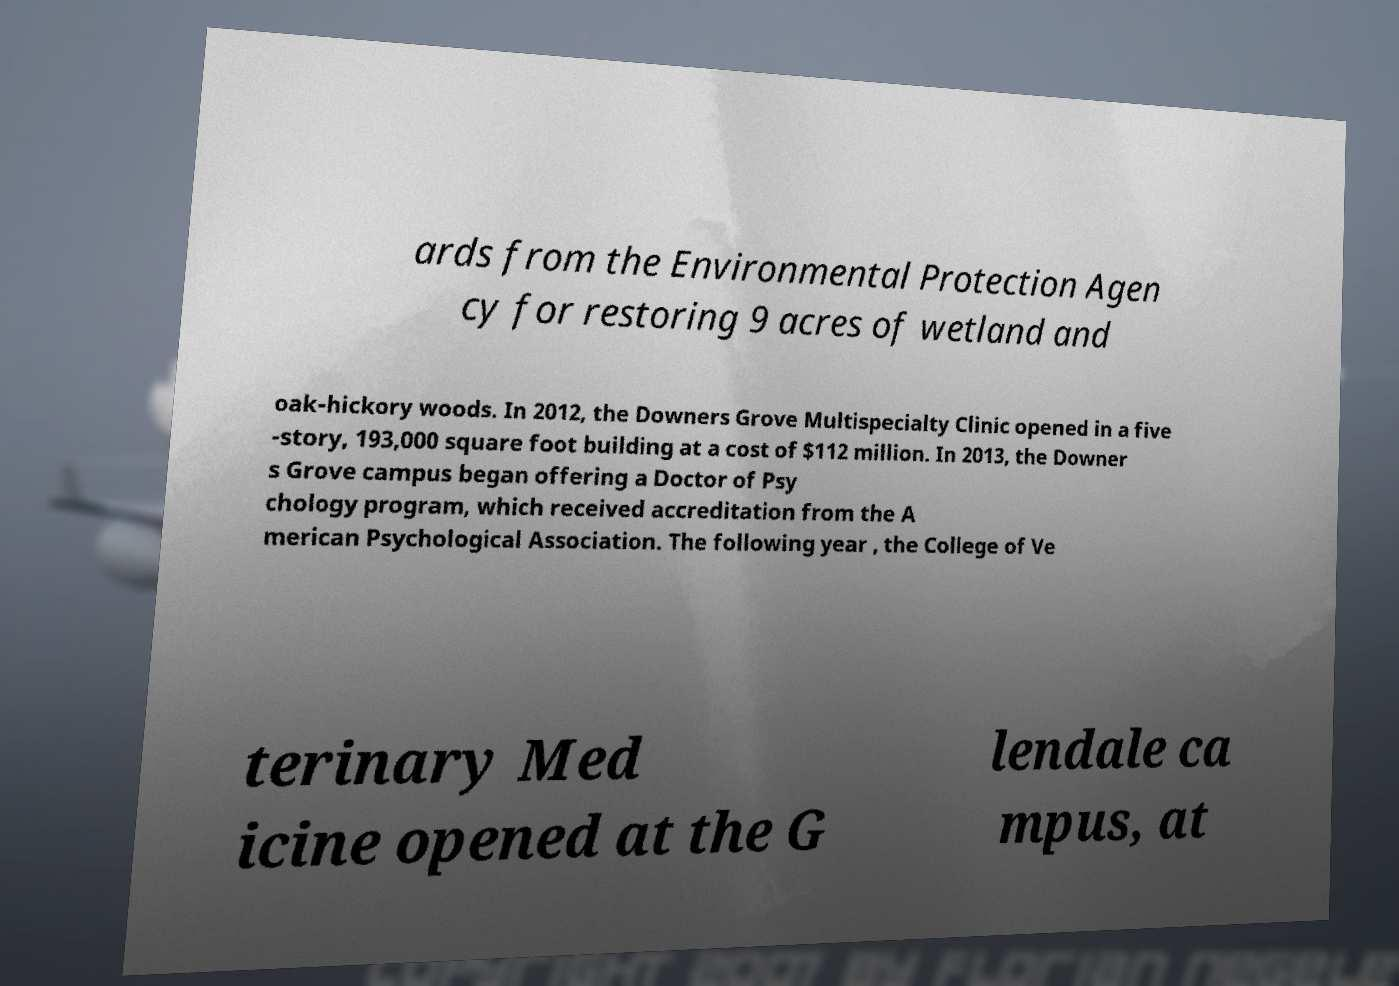For documentation purposes, I need the text within this image transcribed. Could you provide that? ards from the Environmental Protection Agen cy for restoring 9 acres of wetland and oak-hickory woods. In 2012, the Downers Grove Multispecialty Clinic opened in a five -story, 193,000 square foot building at a cost of $112 million. In 2013, the Downer s Grove campus began offering a Doctor of Psy chology program, which received accreditation from the A merican Psychological Association. The following year , the College of Ve terinary Med icine opened at the G lendale ca mpus, at 